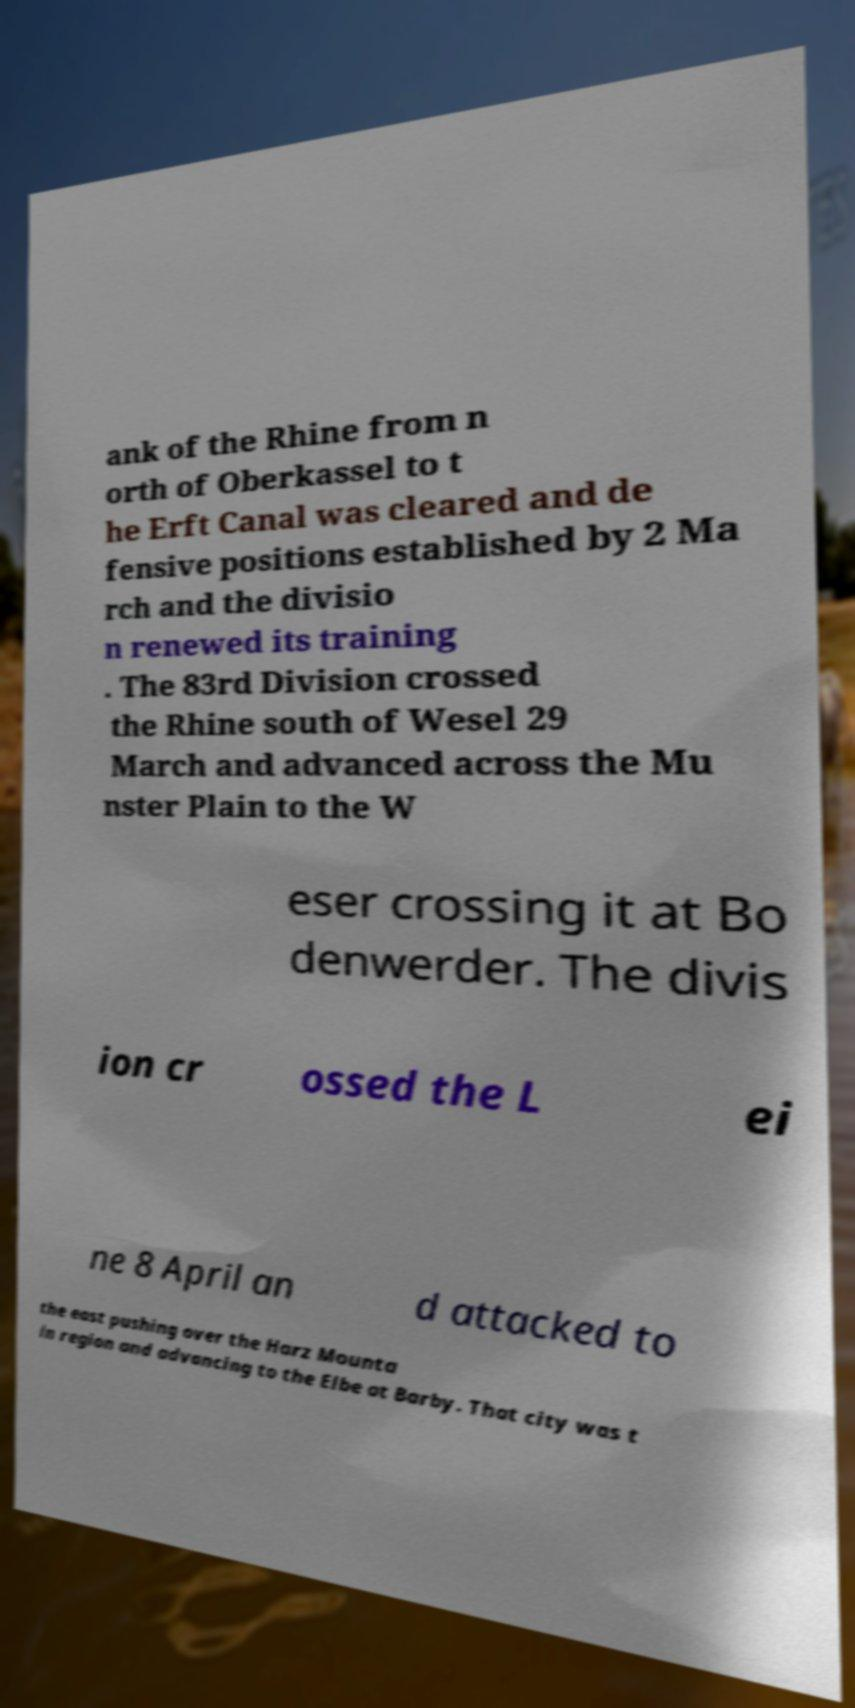Please identify and transcribe the text found in this image. ank of the Rhine from n orth of Oberkassel to t he Erft Canal was cleared and de fensive positions established by 2 Ma rch and the divisio n renewed its training . The 83rd Division crossed the Rhine south of Wesel 29 March and advanced across the Mu nster Plain to the W eser crossing it at Bo denwerder. The divis ion cr ossed the L ei ne 8 April an d attacked to the east pushing over the Harz Mounta in region and advancing to the Elbe at Barby. That city was t 